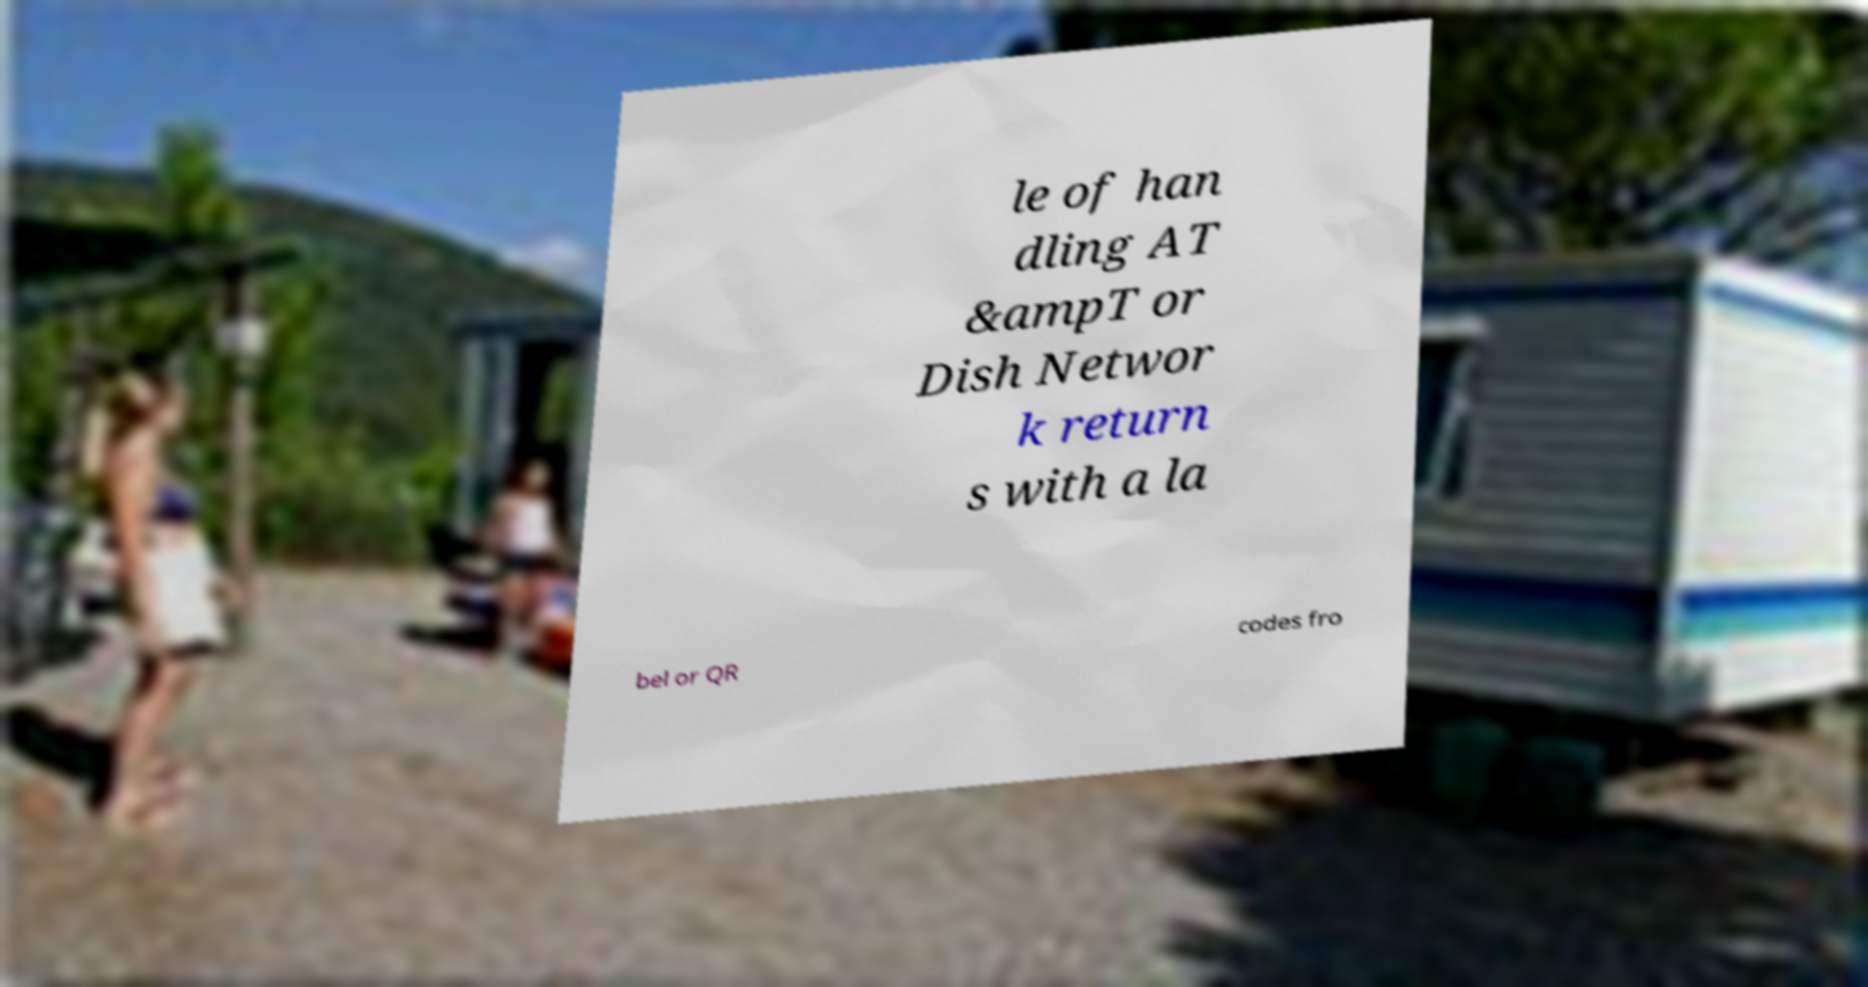Can you accurately transcribe the text from the provided image for me? le of han dling AT &ampT or Dish Networ k return s with a la bel or QR codes fro 